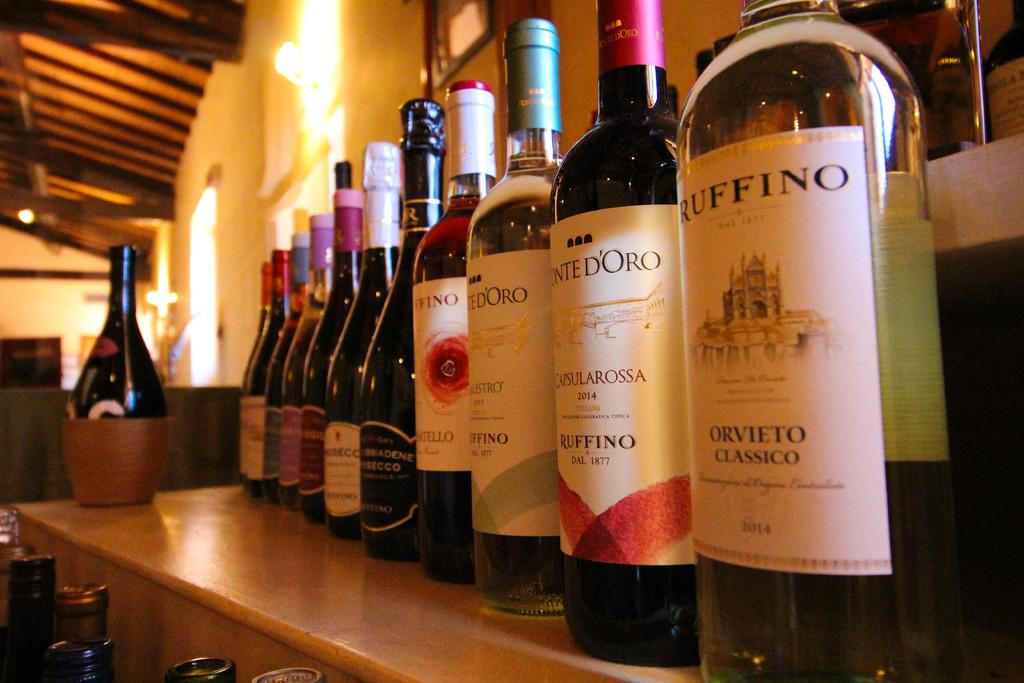<image>
Relay a brief, clear account of the picture shown. several bottles of wine in a line, with an Orvieto Classico on the far right. 